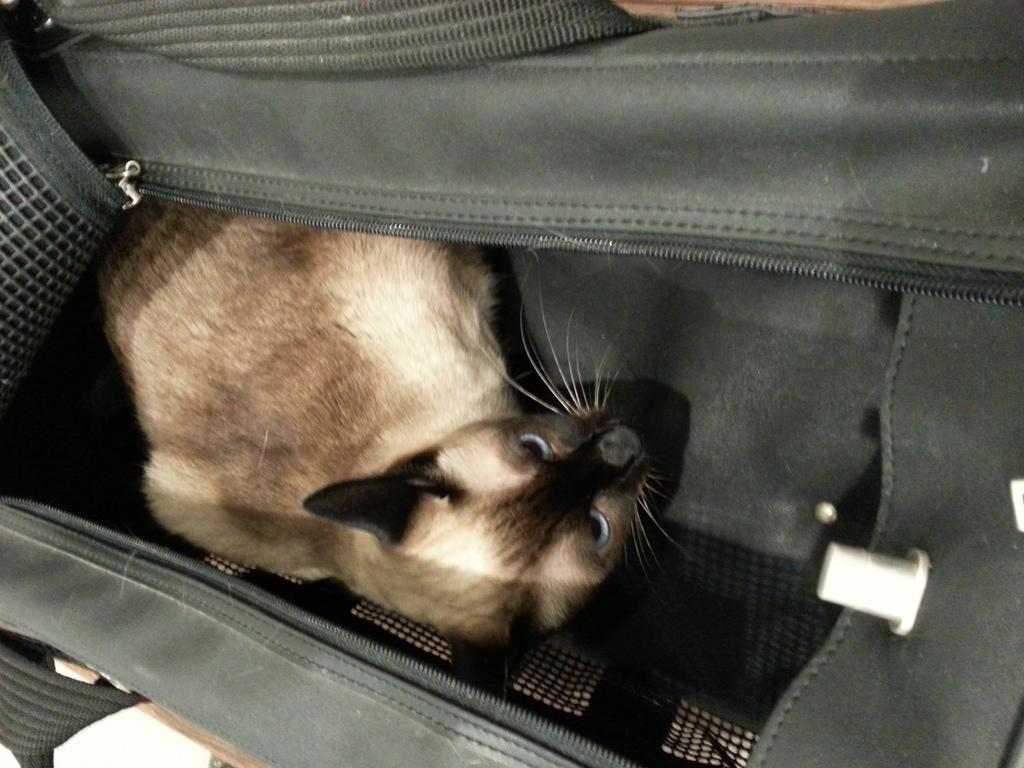What object can be seen in the image? There is a bag in the image. What is the color of the bag? The bag is black in color. What is sitting inside the bag? There is a cat sitting in the bag. How does the bag contribute to pollution in the image? The image does not show any pollution, and the bag itself is not contributing to pollution in the image. 